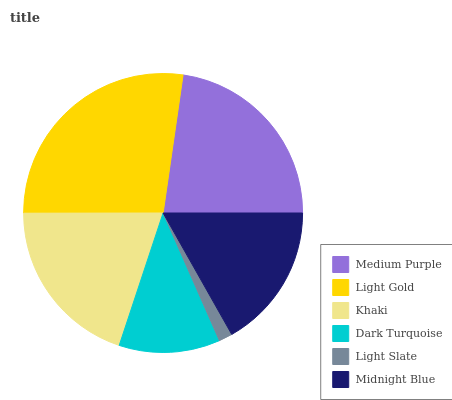Is Light Slate the minimum?
Answer yes or no. Yes. Is Light Gold the maximum?
Answer yes or no. Yes. Is Khaki the minimum?
Answer yes or no. No. Is Khaki the maximum?
Answer yes or no. No. Is Light Gold greater than Khaki?
Answer yes or no. Yes. Is Khaki less than Light Gold?
Answer yes or no. Yes. Is Khaki greater than Light Gold?
Answer yes or no. No. Is Light Gold less than Khaki?
Answer yes or no. No. Is Khaki the high median?
Answer yes or no. Yes. Is Midnight Blue the low median?
Answer yes or no. Yes. Is Midnight Blue the high median?
Answer yes or no. No. Is Khaki the low median?
Answer yes or no. No. 